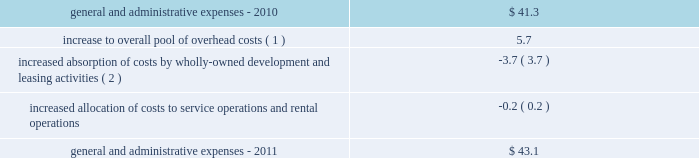32| | duke realty corporation annual report 2012 2022 in 2010 , we sold approximately 60 acres of land , in two separate transactions , which resulted in impairment charges of $ 9.8 million .
These sales were opportunistic in nature and we had not identified or actively marketed this land for disposition , as it was previously intended to be held for development .
General and administrative expenses general and administrative expenses increased from $ 41.3 million in 2010 to $ 43.1 million in 2011 .
The table sets forth the factors that led to the increase in general and administrative expenses from 2010 to 2011 ( in millions ) : .
Interest expense interest expense from continuing operations increased from $ 186.4 million in 2010 to $ 220.5 million in 2011 .
The increase was primarily a result of increased average outstanding debt during 2011 compared to 2010 , which was driven by our acquisition activities as well as other uses of capital .
A $ 7.2 million decrease in the capitalization of interest costs , the result of developed properties no longer meeting the criteria for interest capitalization , also contributed to the increase in interest expense .
Gain ( loss ) on debt transactions there were no gains or losses on debt transactions during 2011 .
During 2010 , through a cash tender offer and open market transactions , we repurchased certain of our outstanding series of unsecured notes scheduled to mature in 2011 and 2013 .
In total , we paid $ 292.2 million for unsecured notes that had a face value of $ 279.9 million .
We recognized a net loss on extinguishment of $ 16.3 million after considering the write-off of unamortized deferred financing costs , discounts and other accounting adjustments .
Acquisition-related activity during 2011 , we recognized approximately $ 2.3 million in acquisition costs , compared to $ 1.9 million of such costs in 2010 .
During 2011 , we also recognized a $ 1.1 million gain related to the acquisition of a building from one of our 50%-owned unconsolidated joint ventures , compared to a $ 57.7 million gain in 2010 on the acquisition of our joint venture partner 2019s 50% ( 50 % ) interest in dugan .
Critical accounting policies the preparation of our consolidated financial statements in conformity with gaap requires us to make estimates and assumptions that affect the reported amounts of assets and liabilities and disclosure of contingent assets and liabilities at the date of the financial statements and the reported amounts of revenues and expenses during the reported period .
Our estimates , judgments and assumptions are inherently subjective and based on the existing business and market conditions , and are therefore continually evaluated based upon available information and experience .
Note 2 to the consolidated financial statements includes further discussion of our significant accounting policies .
Our management has assessed the accounting policies used in the preparation of our financial statements and discussed them with our audit committee and independent auditors .
The following accounting policies are considered critical based upon materiality to the financial statements , degree of judgment involved in estimating reported amounts and sensitivity to changes in industry and economic conditions : ( 1 ) the increase to our overall pool of overhead costs from 2010 is largely due to increased severance pay related to overhead reductions that took place near the end of 2011 .
( 2 ) our total leasing activity increased and we also increased wholly owned development activities from 2010 .
We capitalized $ 25.3 million and $ 10.4 million of our total overhead costs to leasing and development , respectively , for consolidated properties during 2011 , compared to capitalizing $ 23.5 million and $ 8.5 million of such costs , respectively , for 2010 .
Combined overhead costs capitalized to leasing and development totaled 20.6% ( 20.6 % ) and 19.1% ( 19.1 % ) of our overall pool of overhead costs for 2011 and 2010 , respectively. .
In 2011 what was the percent change in the general and administrative expenses? 
Computations: (43.1 - 41.3)
Answer: 1.8. 